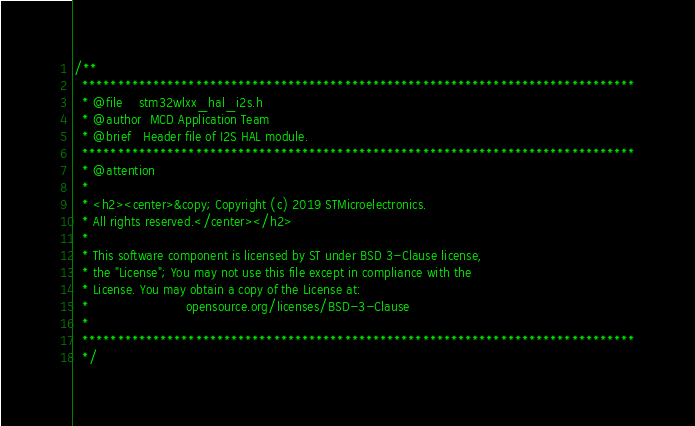<code> <loc_0><loc_0><loc_500><loc_500><_C_>/**
  ******************************************************************************
  * @file    stm32wlxx_hal_i2s.h
  * @author  MCD Application Team
  * @brief   Header file of I2S HAL module.
  ******************************************************************************
  * @attention
  *
  * <h2><center>&copy; Copyright (c) 2019 STMicroelectronics.
  * All rights reserved.</center></h2>
  *
  * This software component is licensed by ST under BSD 3-Clause license,
  * the "License"; You may not use this file except in compliance with the
  * License. You may obtain a copy of the License at:
  *                        opensource.org/licenses/BSD-3-Clause
  *
  ******************************************************************************
  */
</code> 